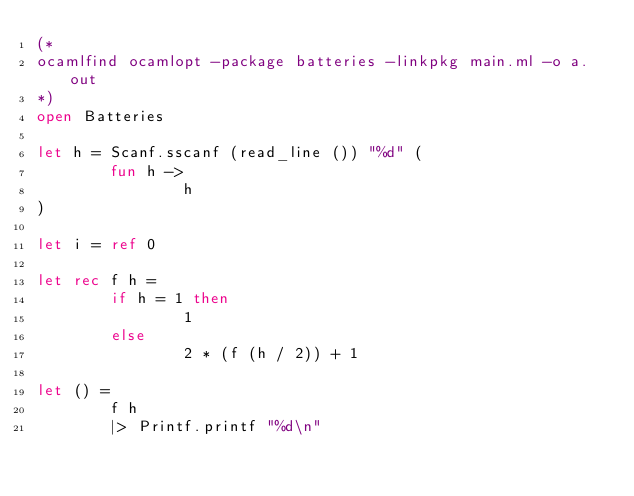<code> <loc_0><loc_0><loc_500><loc_500><_OCaml_>(*
ocamlfind ocamlopt -package batteries -linkpkg main.ml -o a.out
*)
open Batteries

let h = Scanf.sscanf (read_line ()) "%d" (
        fun h -> 
                h
)

let i = ref 0

let rec f h =
        if h = 1 then
                1
        else
                2 * (f (h / 2)) + 1

let () =
        f h
        |> Printf.printf "%d\n"
</code> 